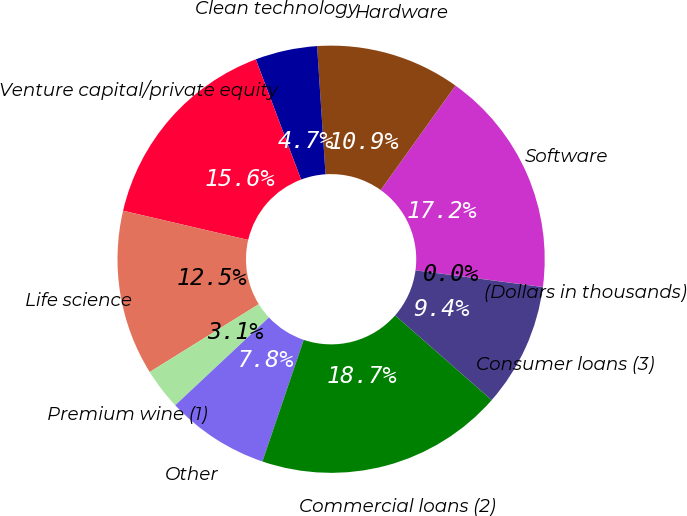<chart> <loc_0><loc_0><loc_500><loc_500><pie_chart><fcel>(Dollars in thousands)<fcel>Software<fcel>Hardware<fcel>Clean technology<fcel>Venture capital/private equity<fcel>Life science<fcel>Premium wine (1)<fcel>Other<fcel>Commercial loans (2)<fcel>Consumer loans (3)<nl><fcel>0.01%<fcel>17.18%<fcel>10.94%<fcel>4.69%<fcel>15.62%<fcel>12.5%<fcel>3.13%<fcel>7.81%<fcel>18.75%<fcel>9.38%<nl></chart> 